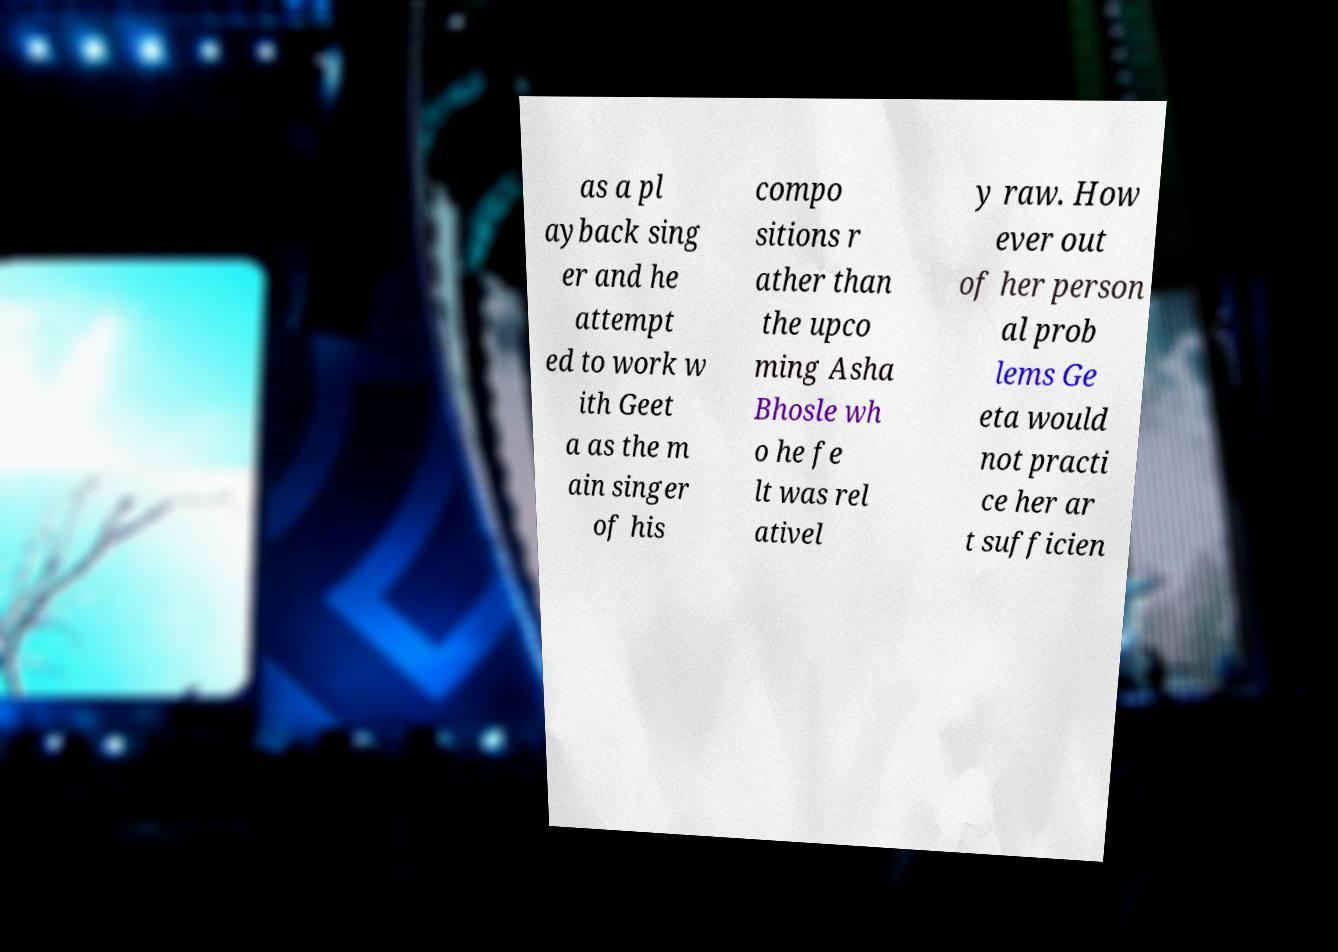Can you read and provide the text displayed in the image?This photo seems to have some interesting text. Can you extract and type it out for me? as a pl ayback sing er and he attempt ed to work w ith Geet a as the m ain singer of his compo sitions r ather than the upco ming Asha Bhosle wh o he fe lt was rel ativel y raw. How ever out of her person al prob lems Ge eta would not practi ce her ar t sufficien 